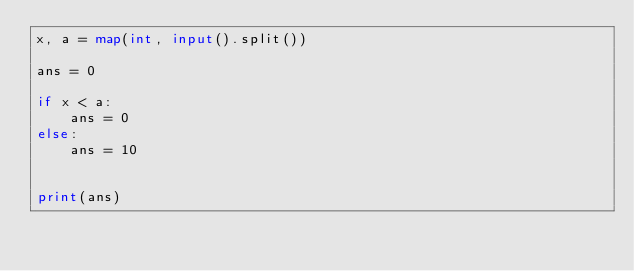<code> <loc_0><loc_0><loc_500><loc_500><_Python_>x, a = map(int, input().split())

ans = 0

if x < a:
    ans = 0
else:
    ans = 10


print(ans)</code> 